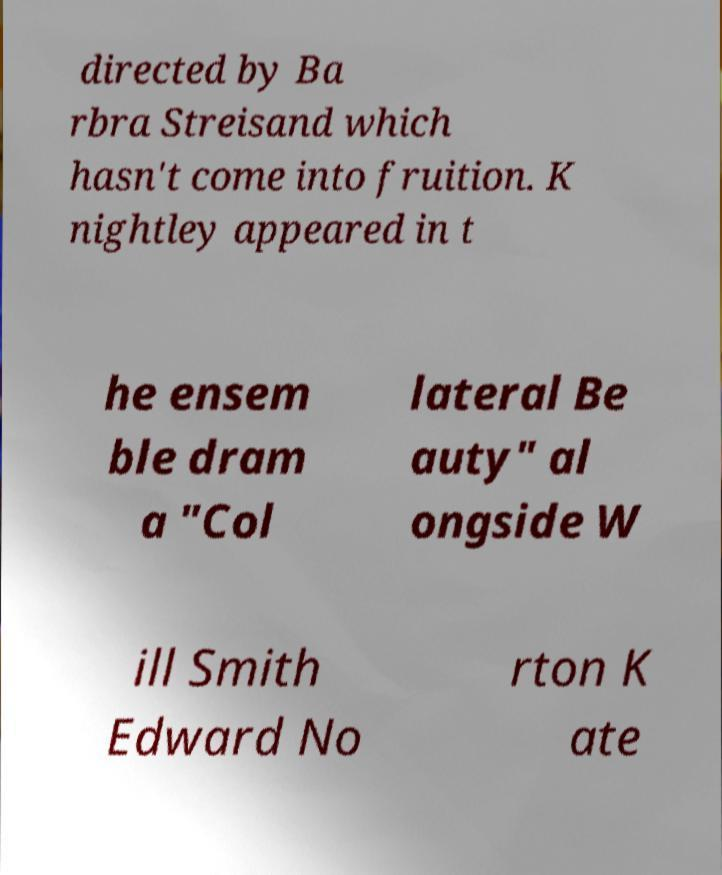I need the written content from this picture converted into text. Can you do that? directed by Ba rbra Streisand which hasn't come into fruition. K nightley appeared in t he ensem ble dram a "Col lateral Be auty" al ongside W ill Smith Edward No rton K ate 